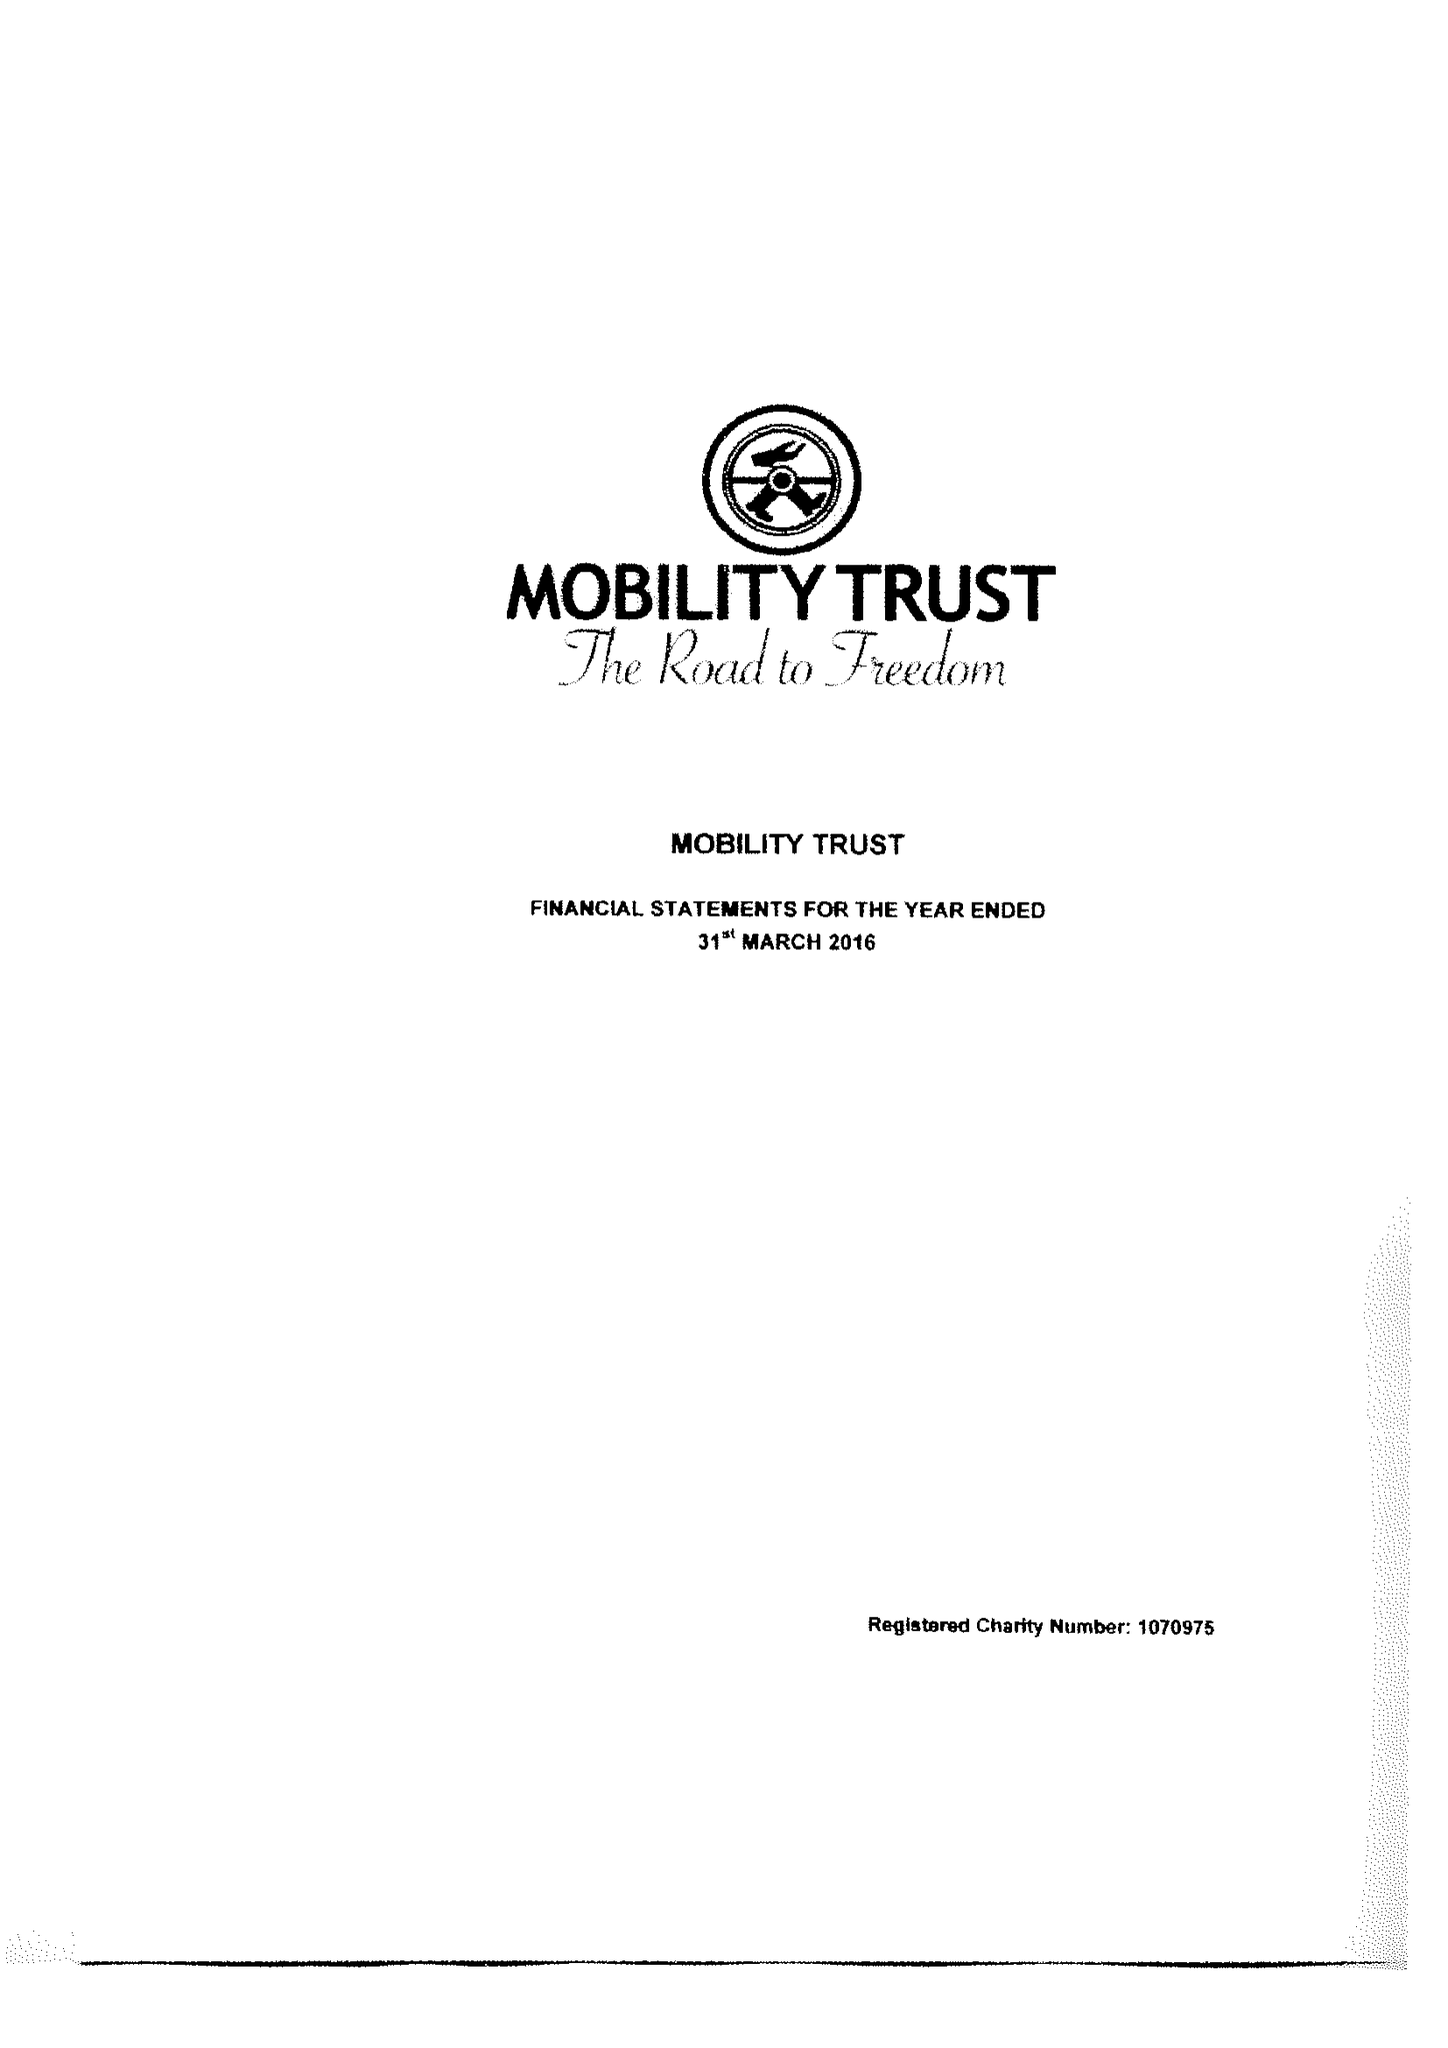What is the value for the charity_name?
Answer the question using a single word or phrase. Mobility Trust Ii 